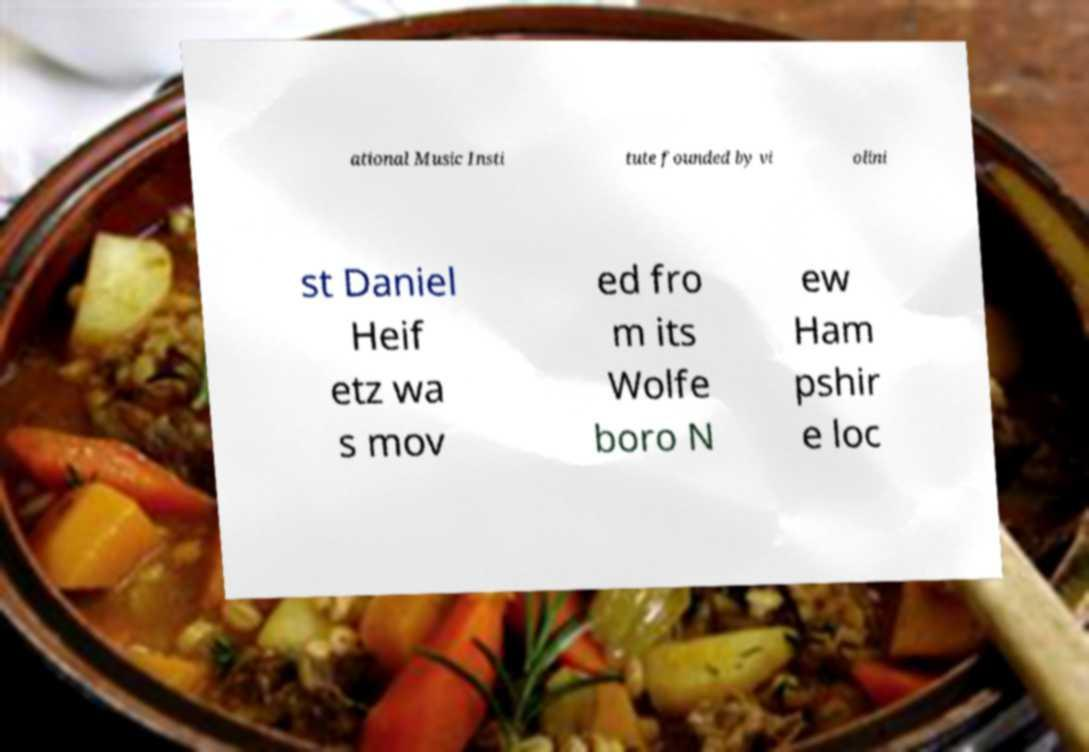Please identify and transcribe the text found in this image. ational Music Insti tute founded by vi olini st Daniel Heif etz wa s mov ed fro m its Wolfe boro N ew Ham pshir e loc 